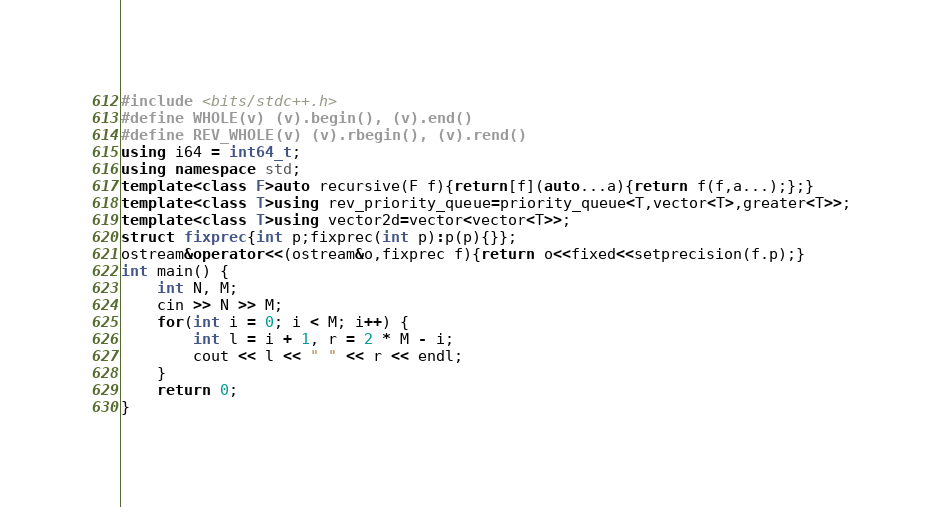Convert code to text. <code><loc_0><loc_0><loc_500><loc_500><_C++_>#include <bits/stdc++.h>
#define WHOLE(v) (v).begin(), (v).end()
#define REV_WHOLE(v) (v).rbegin(), (v).rend()
using i64 = int64_t;
using namespace std;
template<class F>auto recursive(F f){return[f](auto...a){return f(f,a...);};}
template<class T>using rev_priority_queue=priority_queue<T,vector<T>,greater<T>>;
template<class T>using vector2d=vector<vector<T>>;
struct fixprec{int p;fixprec(int p):p(p){}};
ostream&operator<<(ostream&o,fixprec f){return o<<fixed<<setprecision(f.p);}
int main() {
    int N, M;
    cin >> N >> M;
    for(int i = 0; i < M; i++) {
        int l = i + 1, r = 2 * M - i;
        cout << l << " " << r << endl;
    }
    return 0;
}</code> 